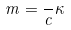Convert formula to latex. <formula><loc_0><loc_0><loc_500><loc_500>m = \frac { } { c } \kappa</formula> 